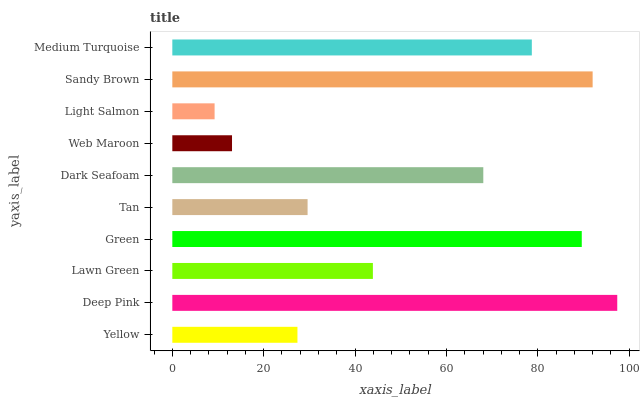Is Light Salmon the minimum?
Answer yes or no. Yes. Is Deep Pink the maximum?
Answer yes or no. Yes. Is Lawn Green the minimum?
Answer yes or no. No. Is Lawn Green the maximum?
Answer yes or no. No. Is Deep Pink greater than Lawn Green?
Answer yes or no. Yes. Is Lawn Green less than Deep Pink?
Answer yes or no. Yes. Is Lawn Green greater than Deep Pink?
Answer yes or no. No. Is Deep Pink less than Lawn Green?
Answer yes or no. No. Is Dark Seafoam the high median?
Answer yes or no. Yes. Is Lawn Green the low median?
Answer yes or no. Yes. Is Sandy Brown the high median?
Answer yes or no. No. Is Tan the low median?
Answer yes or no. No. 